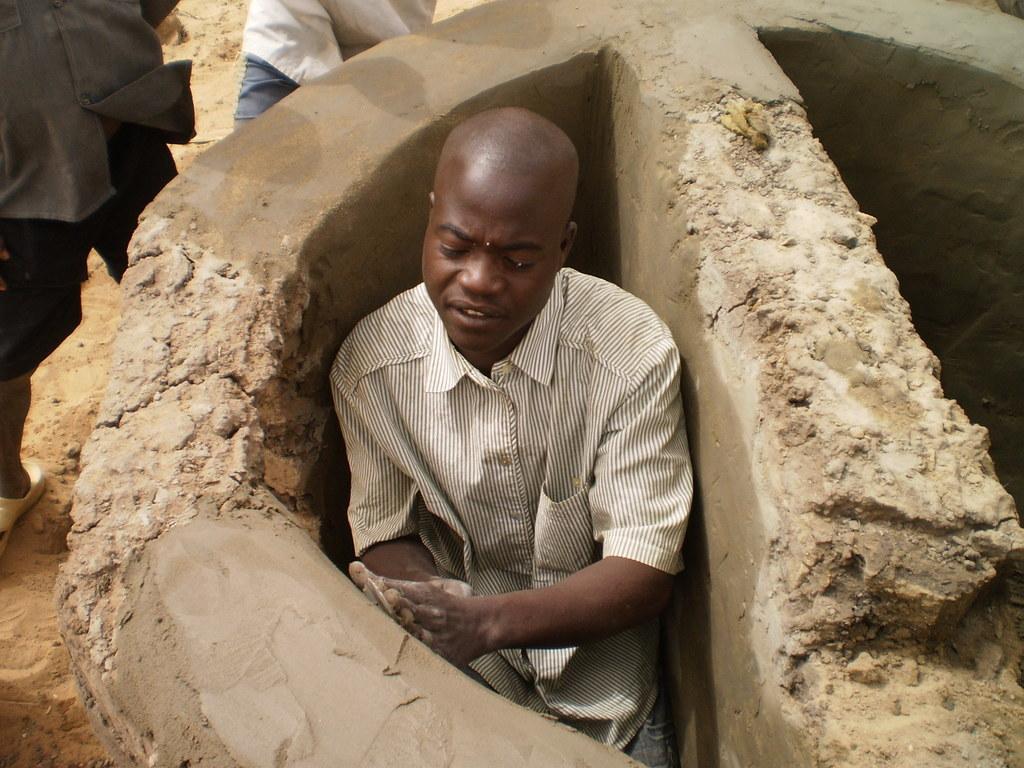Can you describe this image briefly? In this image we can see a man plastering the wall. In the background we can also see two persons standing on the sand. 